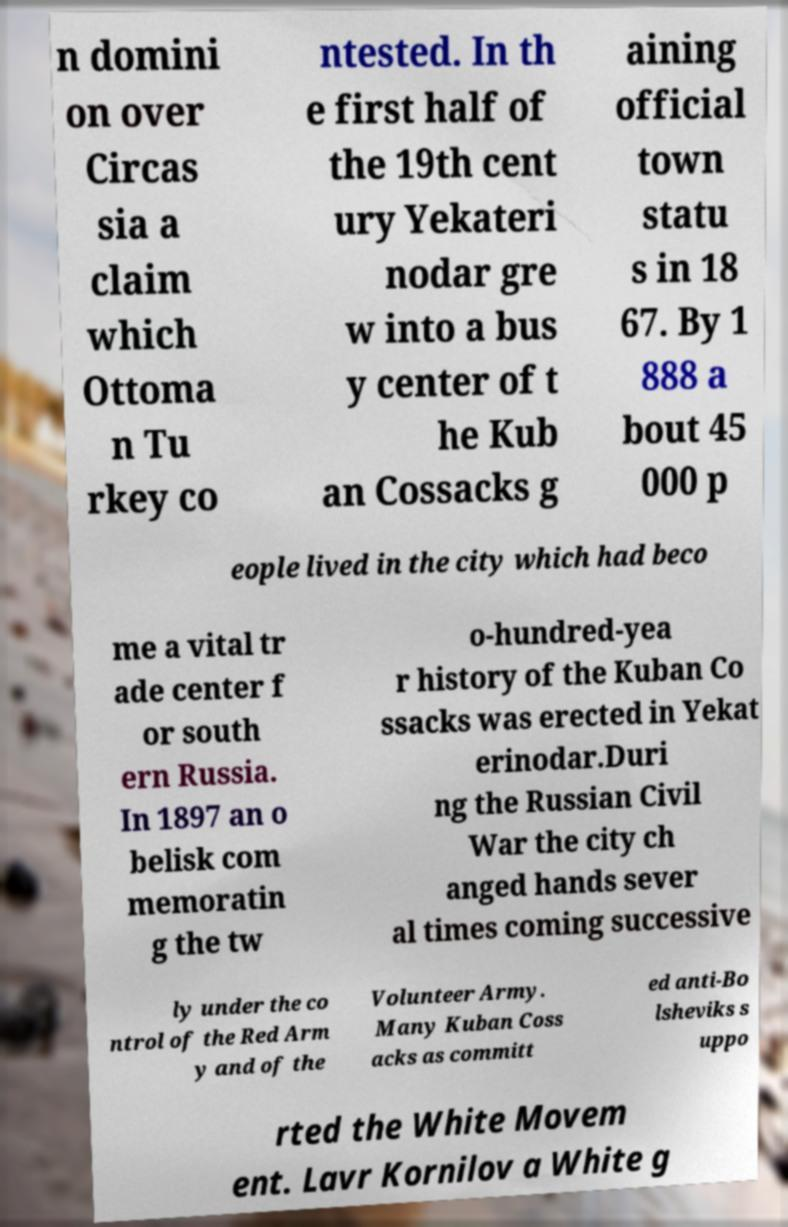For documentation purposes, I need the text within this image transcribed. Could you provide that? n domini on over Circas sia a claim which Ottoma n Tu rkey co ntested. In th e first half of the 19th cent ury Yekateri nodar gre w into a bus y center of t he Kub an Cossacks g aining official town statu s in 18 67. By 1 888 a bout 45 000 p eople lived in the city which had beco me a vital tr ade center f or south ern Russia. In 1897 an o belisk com memoratin g the tw o-hundred-yea r history of the Kuban Co ssacks was erected in Yekat erinodar.Duri ng the Russian Civil War the city ch anged hands sever al times coming successive ly under the co ntrol of the Red Arm y and of the Volunteer Army. Many Kuban Coss acks as committ ed anti-Bo lsheviks s uppo rted the White Movem ent. Lavr Kornilov a White g 